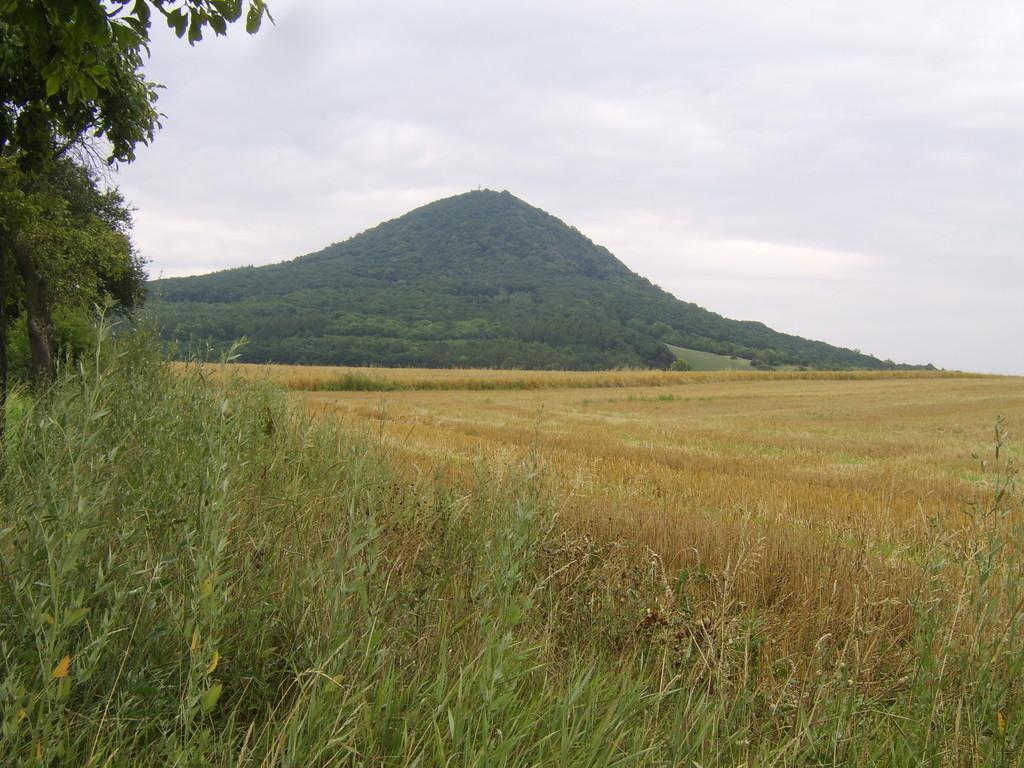In one or two sentences, can you explain what this image depicts? In this picture we can see the land covered with grass and surrounded by trees and grass mountains. The sky is cloudy. 